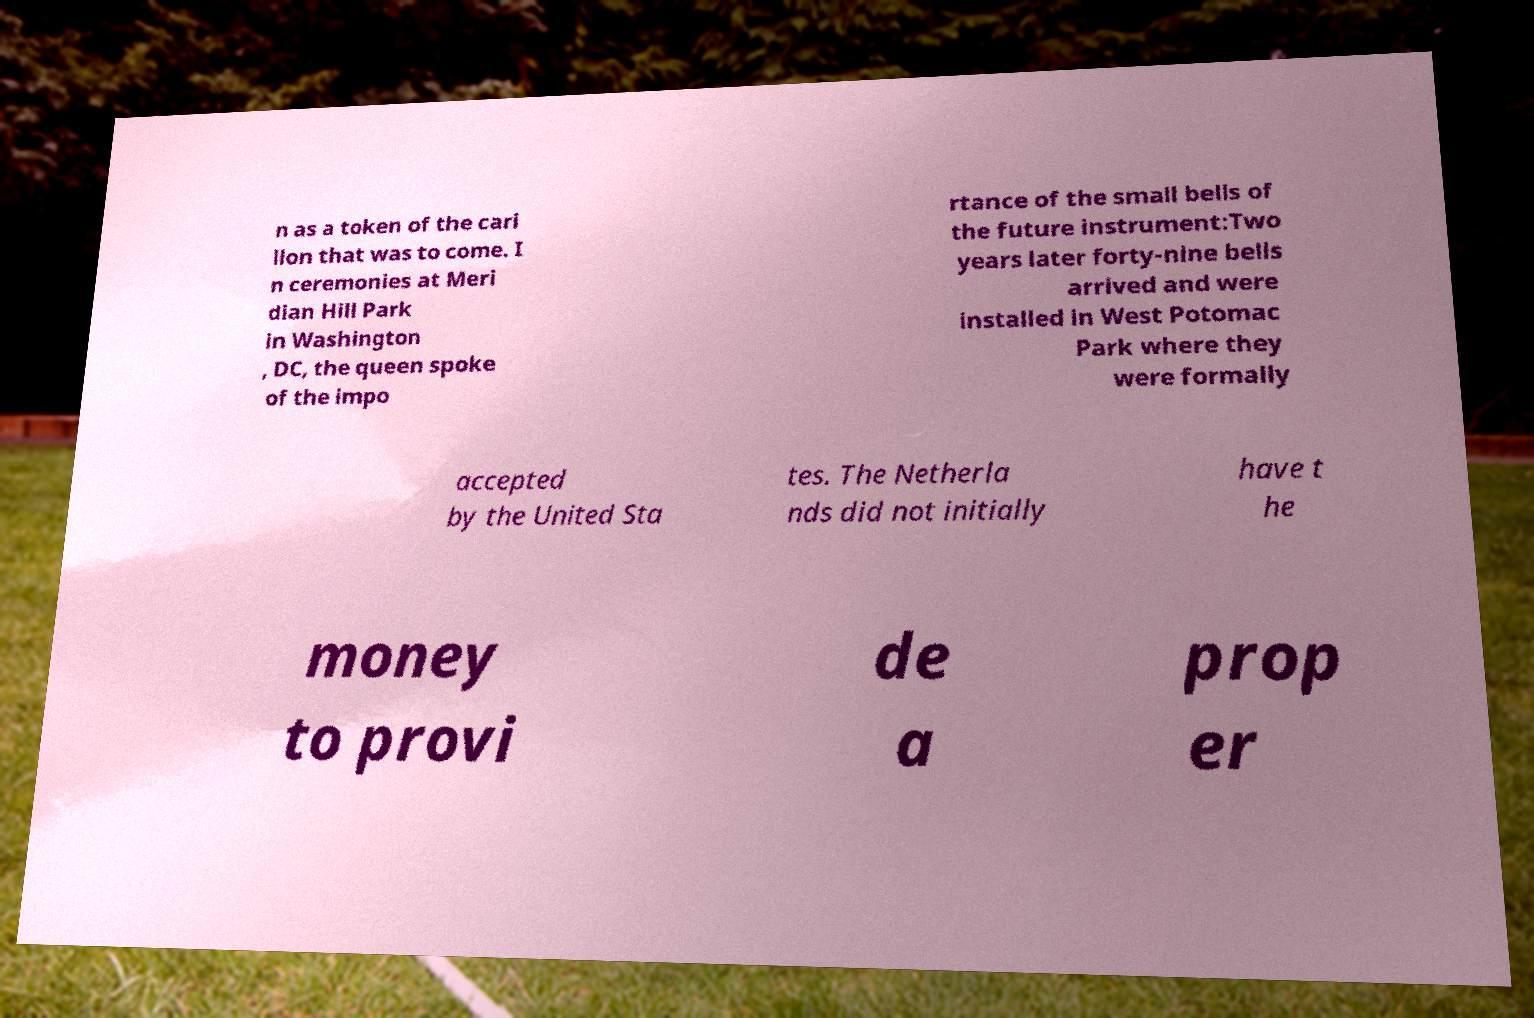Please read and relay the text visible in this image. What does it say? n as a token of the cari llon that was to come. I n ceremonies at Meri dian Hill Park in Washington , DC, the queen spoke of the impo rtance of the small bells of the future instrument:Two years later forty-nine bells arrived and were installed in West Potomac Park where they were formally accepted by the United Sta tes. The Netherla nds did not initially have t he money to provi de a prop er 